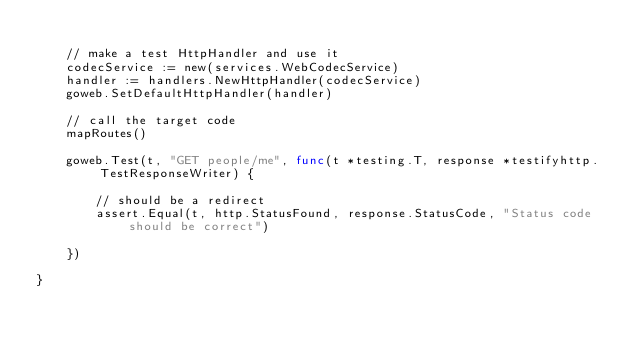Convert code to text. <code><loc_0><loc_0><loc_500><loc_500><_Go_>
	// make a test HttpHandler and use it
	codecService := new(services.WebCodecService)
	handler := handlers.NewHttpHandler(codecService)
	goweb.SetDefaultHttpHandler(handler)

	// call the target code
	mapRoutes()

	goweb.Test(t, "GET people/me", func(t *testing.T, response *testifyhttp.TestResponseWriter) {

		// should be a redirect
		assert.Equal(t, http.StatusFound, response.StatusCode, "Status code should be correct")

	})

}
</code> 